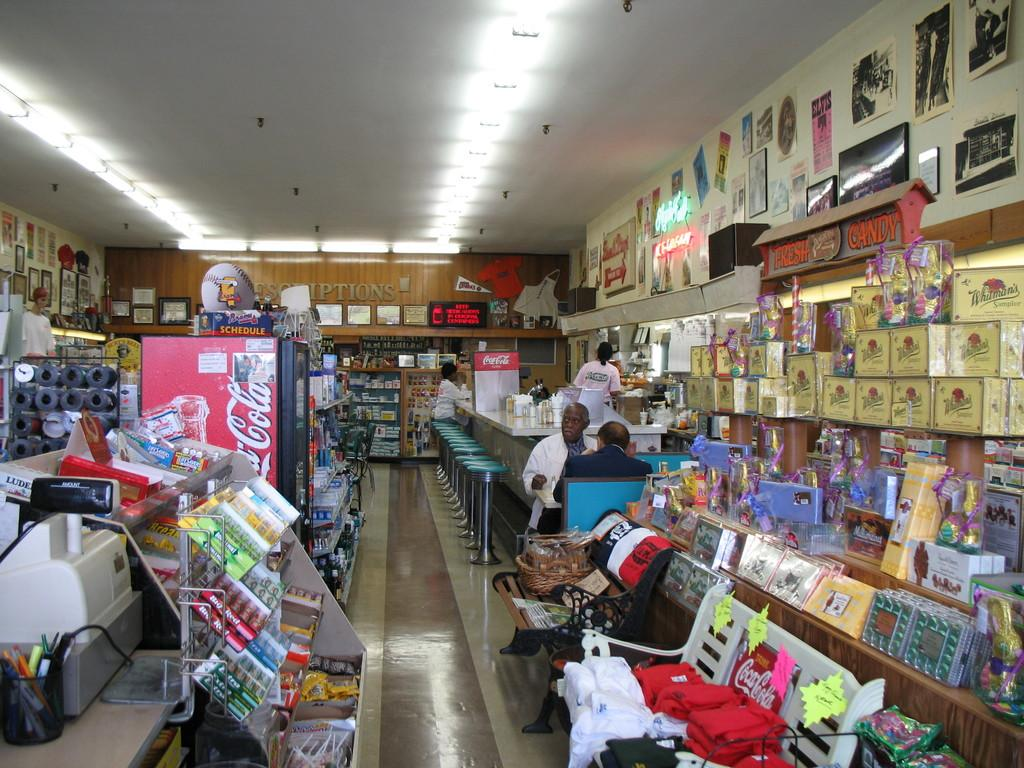<image>
Share a concise interpretation of the image provided. A diner with various items for sale and a Coca Cola drink cooler in the center. 